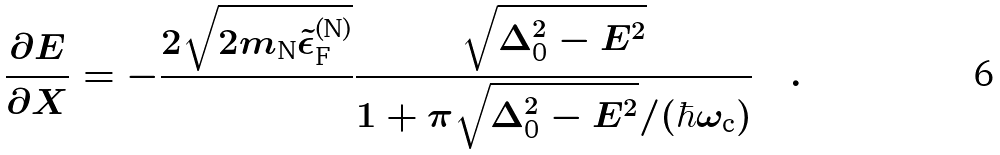<formula> <loc_0><loc_0><loc_500><loc_500>\frac { \partial E } { \partial X } = - \frac { 2 \sqrt { 2 m _ { \text {N} } \tilde { \epsilon } ^ { \text {(N)} } _ { \text {F} } } } { } \frac { \sqrt { \Delta _ { \text {0} } ^ { 2 } - E ^ { 2 } } } { 1 + \pi \sqrt { \Delta _ { \text {0} } ^ { 2 } - E ^ { 2 } } / ( \hbar { \omega } _ { \text {c} } ) } \quad .</formula> 